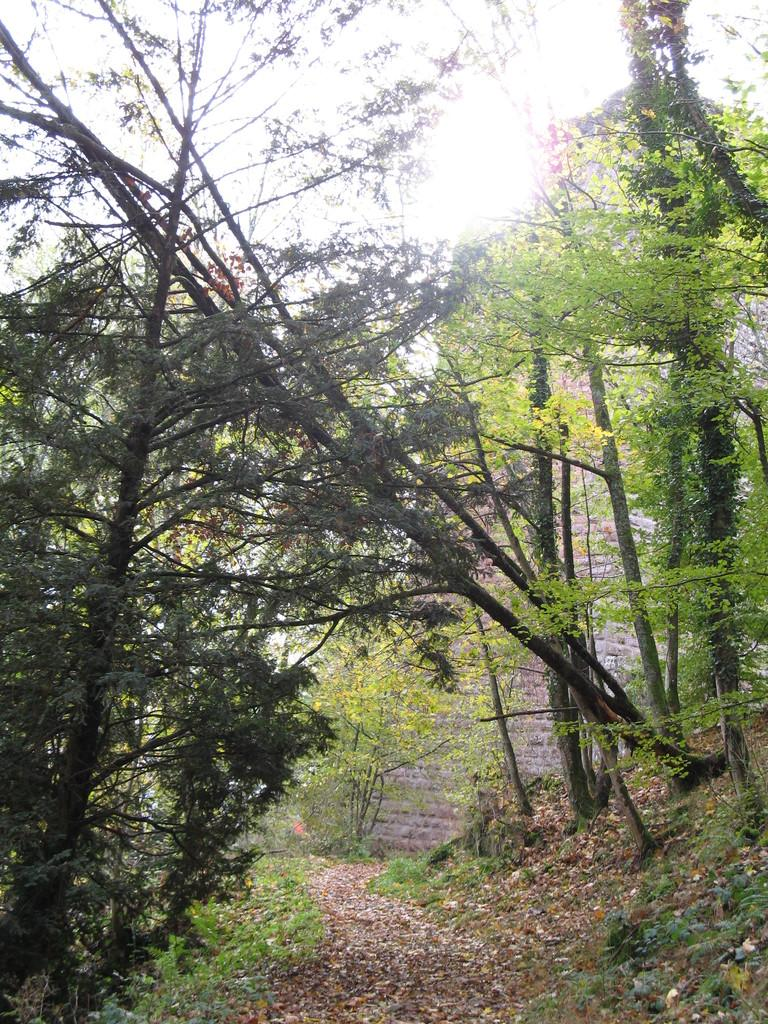What is the main feature of the image? The main feature of the image is a path with dried leaves. What type of vegetation is present alongside the path? Grass and plants are visible on either side of the path. Are there any trees in the image? Yes, trees are present on either side of the path. What type of pen is the lawyer using to work on the path in the image? There is no lawyer or pen present in the image; it features a path with dried leaves and surrounding vegetation. 